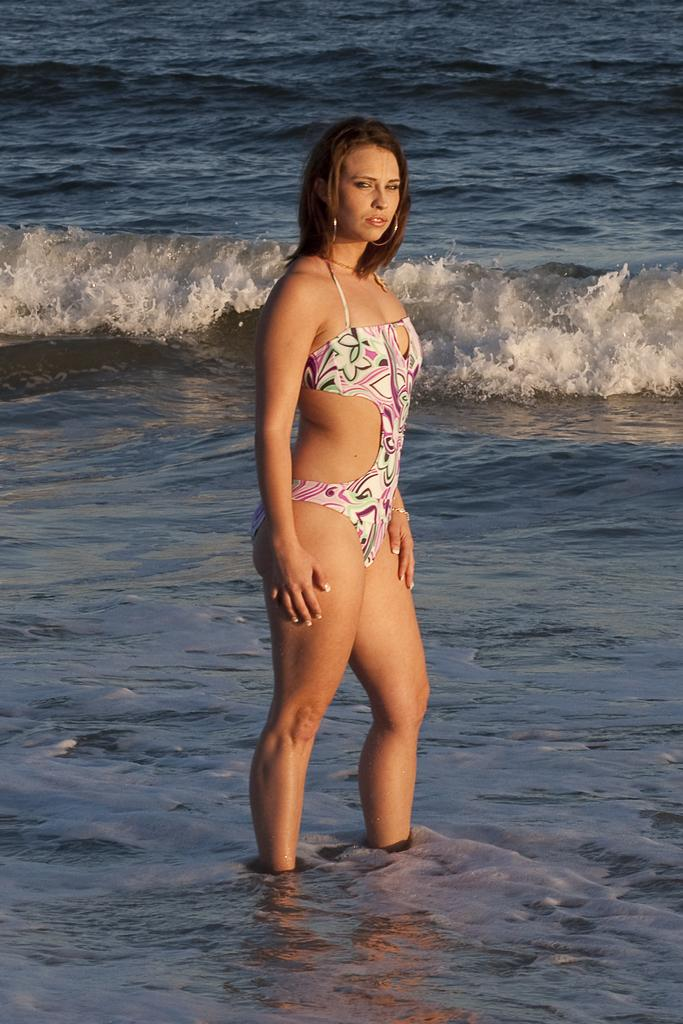Who is present in the image? There is a woman in the image. What is the woman wearing? The woman is wearing a bikini. Where is the woman located in the image? The woman is standing in the water. What can be seen in the background of the image? There is a tide of the ocean in the background of the image. How many goldfish are swimming near the woman in the image? There are no goldfish present in the image; it features a woman standing in the water with a background of the ocean tide. 